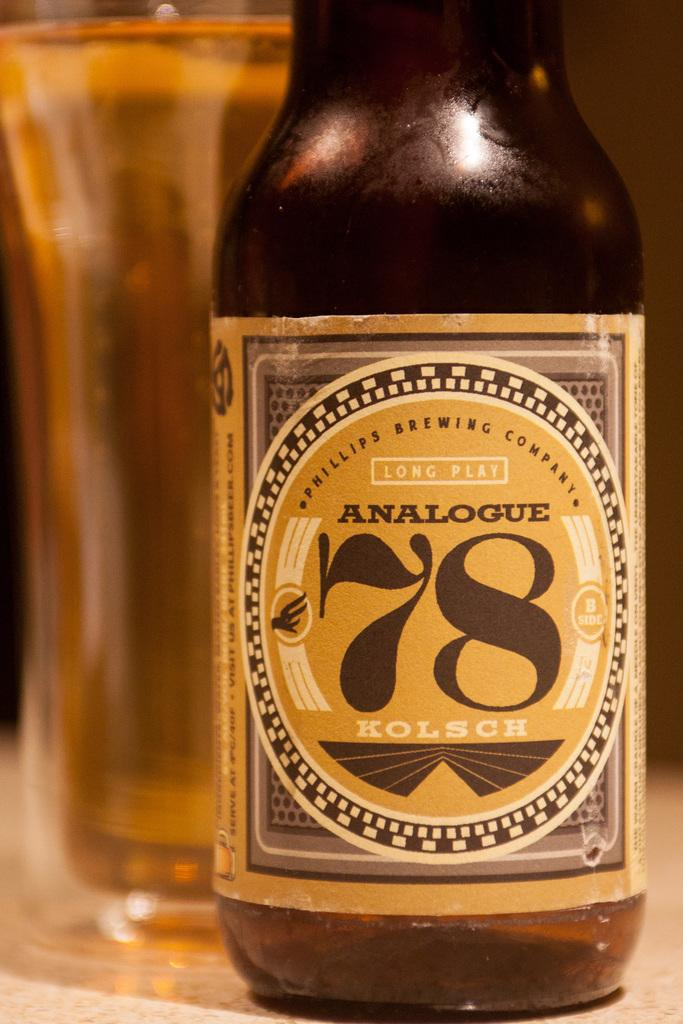<image>
Provide a brief description of the given image. Analogue Kolsch bottle of long plat beer by a glass 